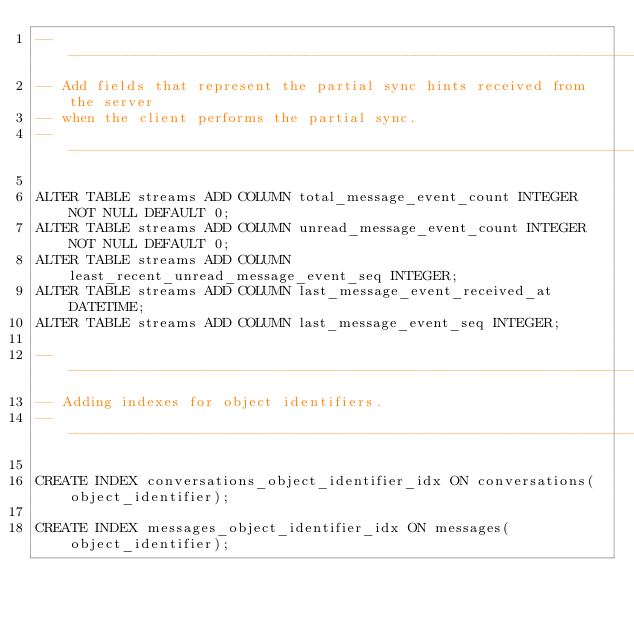<code> <loc_0><loc_0><loc_500><loc_500><_SQL_>-------------------------------------------------------------------------------
-- Add fields that represent the partial sync hints received from the server
-- when the client performs the partial sync.
-------------------------------------------------------------------------------

ALTER TABLE streams ADD COLUMN total_message_event_count INTEGER NOT NULL DEFAULT 0;
ALTER TABLE streams ADD COLUMN unread_message_event_count INTEGER NOT NULL DEFAULT 0;
ALTER TABLE streams ADD COLUMN least_recent_unread_message_event_seq INTEGER;
ALTER TABLE streams ADD COLUMN last_message_event_received_at DATETIME;
ALTER TABLE streams ADD COLUMN last_message_event_seq INTEGER;

-------------------------------------------------------------------------------
-- Adding indexes for object identifiers.
-------------------------------------------------------------------------------

CREATE INDEX conversations_object_identifier_idx ON conversations(object_identifier);

CREATE INDEX messages_object_identifier_idx ON messages(object_identifier);
</code> 